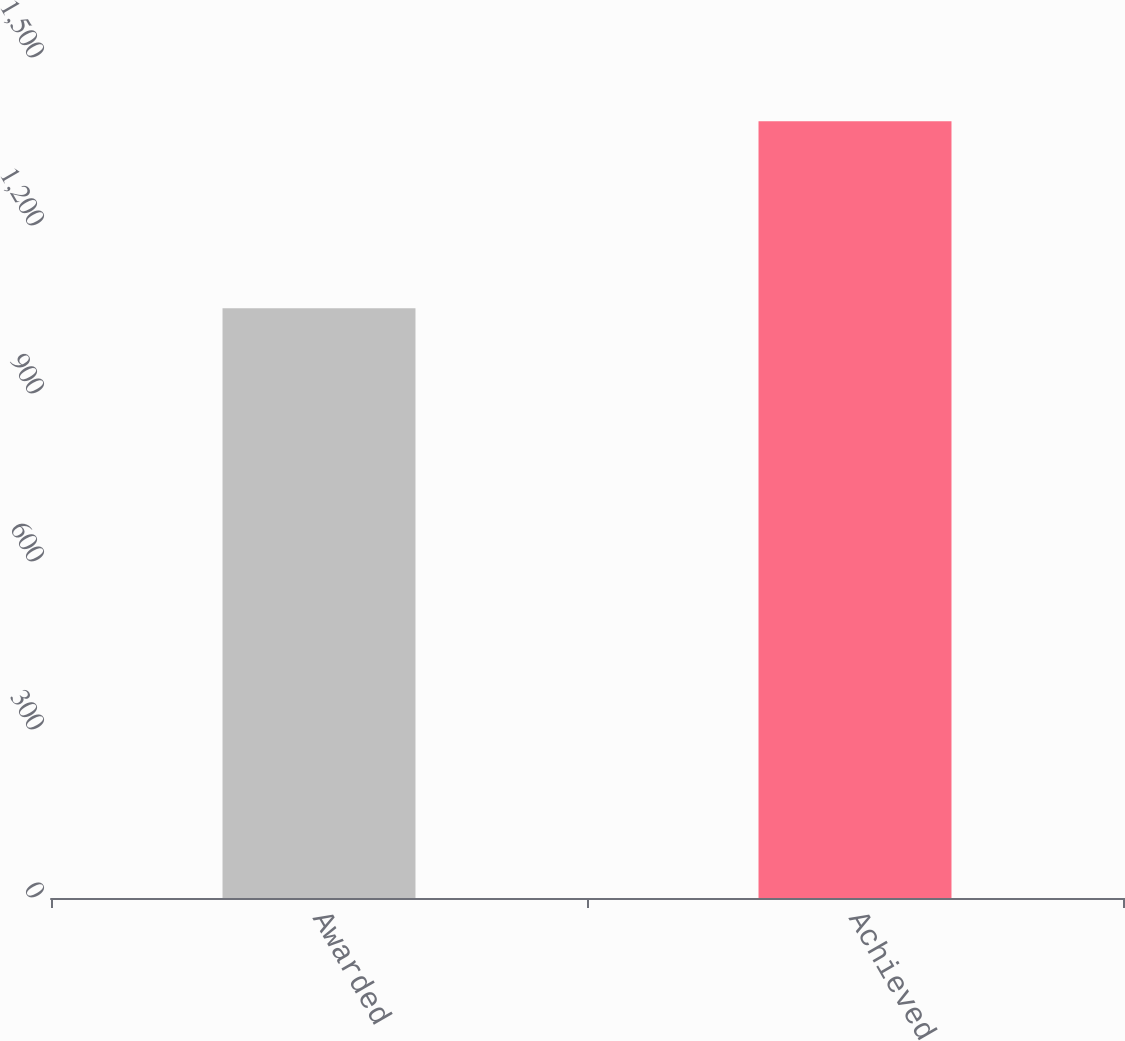Convert chart to OTSL. <chart><loc_0><loc_0><loc_500><loc_500><bar_chart><fcel>Awarded<fcel>Achieved<nl><fcel>1053<fcel>1387<nl></chart> 